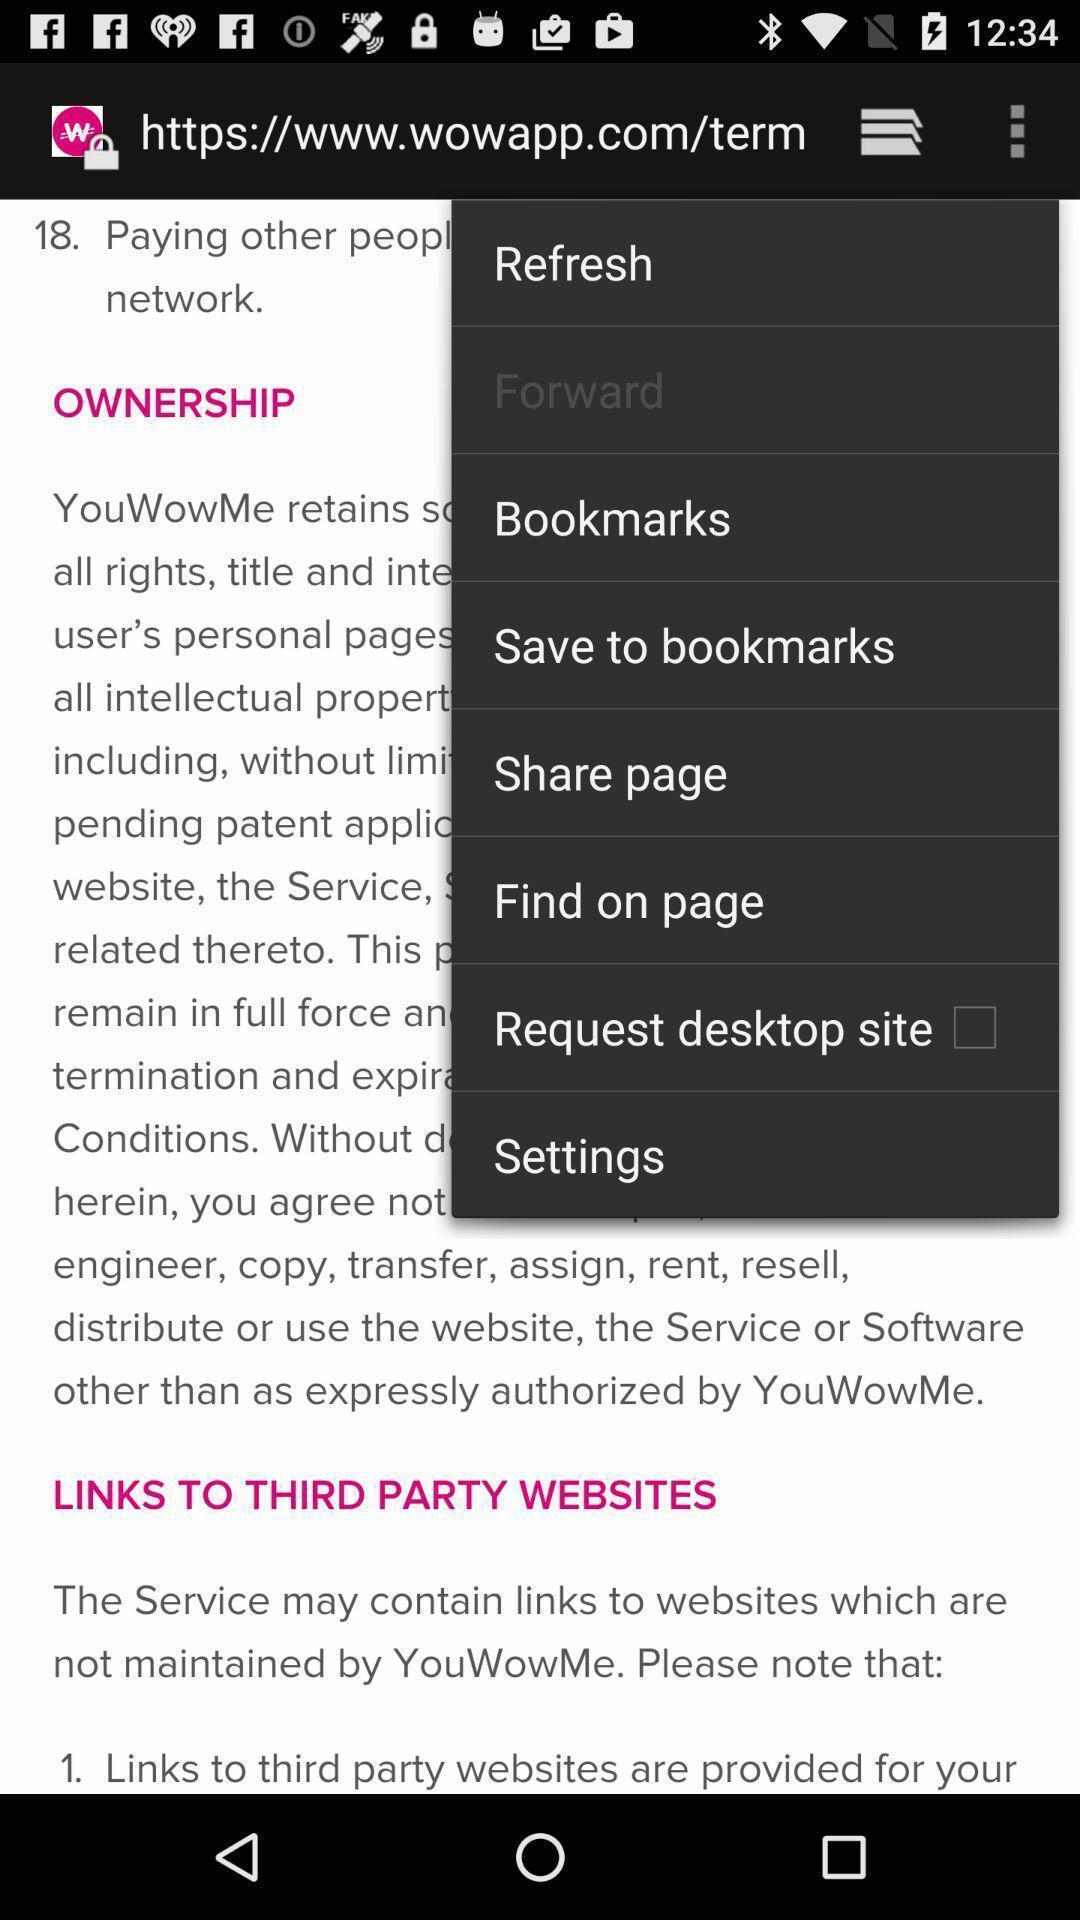Provide a textual representation of this image. Page showing the options in more menu. 